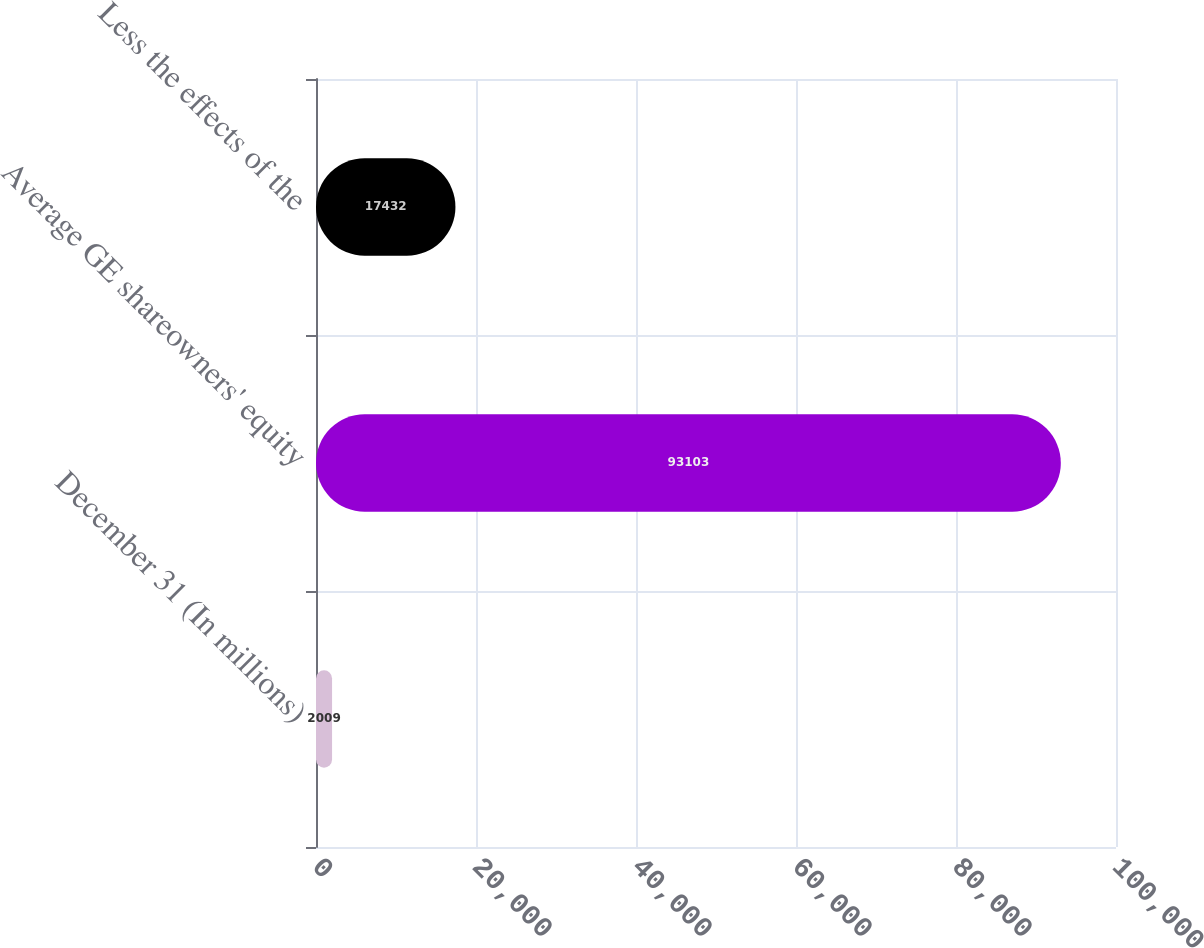<chart> <loc_0><loc_0><loc_500><loc_500><bar_chart><fcel>December 31 (In millions)<fcel>Average GE shareowners' equity<fcel>Less the effects of the<nl><fcel>2009<fcel>93103<fcel>17432<nl></chart> 